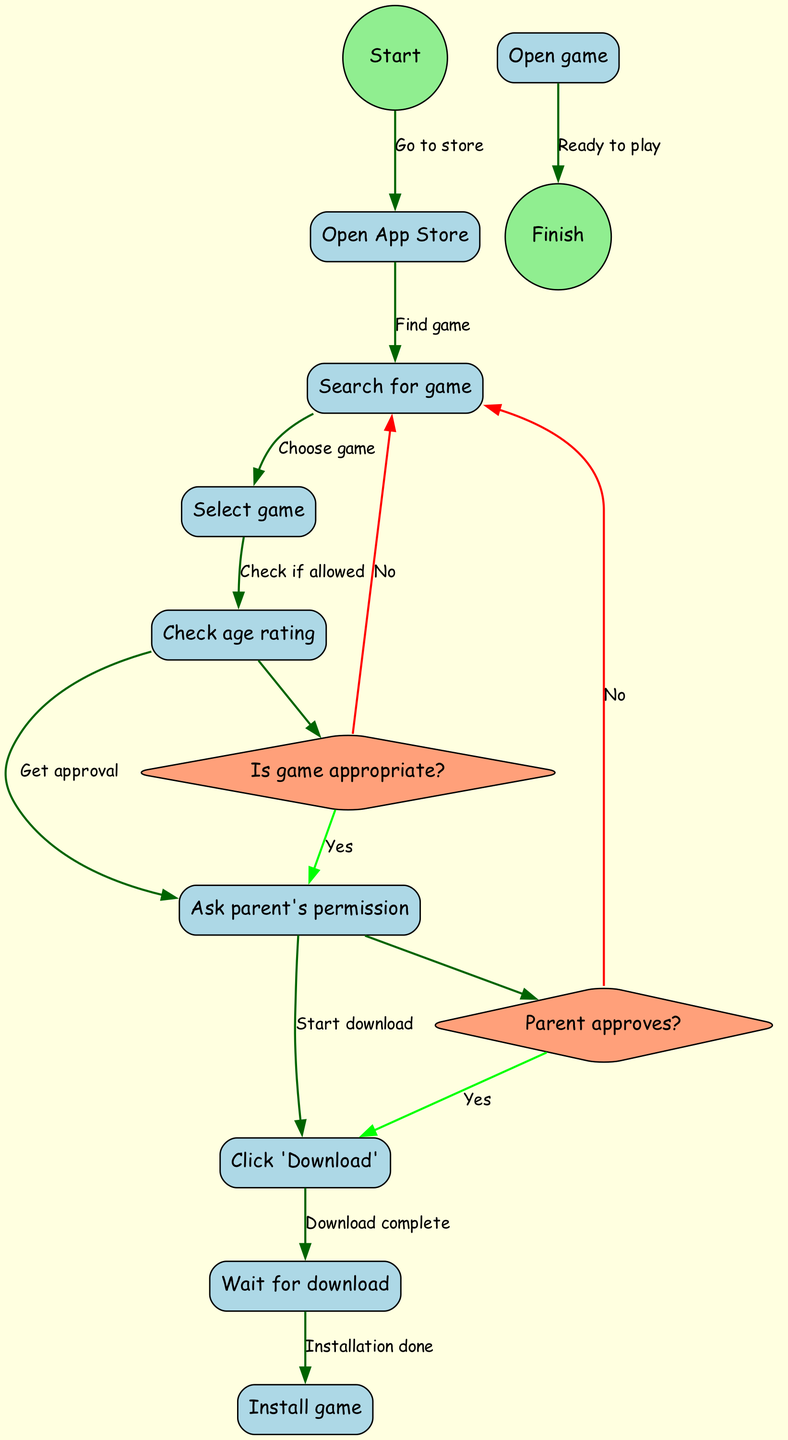What is the first node in the diagram? The first node is listed as "Open App Store" following the "Start" node, which is the entry point to the activity.
Answer: Open App Store How many nodes are present in the diagram? By counting all the individual activities and decision points, there are a total of nine nodes in the diagram.
Answer: 9 What happens if the game is not appropriate? If the game is deemed not appropriate, the flow indicates a return to the "Search for game" node, effectively restarting the process.
Answer: Search for game What action follows after "Wait for download"? The next action after "Wait for download" is labeled "Install game," as the process moves from waiting to installation directly.
Answer: Install game What question is asked before checking age rating? The process involves directly proceeding to the age rating check without a prior question specifically before that node. The sequence begins at the "Check age rating" node.
Answer: None If the parent does not approve, where does the flow go next? If the parent does not give approval, the flow indicates that it returns to the "Search for game," signifying that the process must restart to find another option.
Answer: Search for game How many decision points are in the diagram? There are two decision points in the diagram: one about the game's appropriateness and the other regarding the parent's approval of the game.
Answer: 2 What is the final action before "Finish"? The final action before reaching "Finish" is "Open game," indicating that once the game is installed, the user can start playing.
Answer: Open game What is the edge connecting "Ask parent's permission"? The edge coming from "Ask parent's permission" leads to the decision node "Parent approves?" indicating that permission must be confirmed before proceeding.
Answer: Parent approves? 